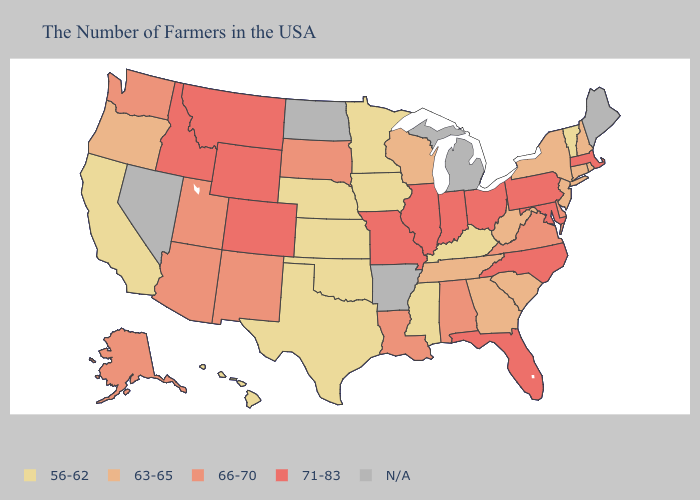Which states hav the highest value in the Northeast?
Keep it brief. Massachusetts, Pennsylvania. Does North Carolina have the lowest value in the South?
Be succinct. No. Is the legend a continuous bar?
Quick response, please. No. Is the legend a continuous bar?
Short answer required. No. Name the states that have a value in the range N/A?
Give a very brief answer. Maine, Michigan, Arkansas, North Dakota, Nevada. What is the value of Kansas?
Give a very brief answer. 56-62. Which states have the lowest value in the USA?
Quick response, please. Vermont, Kentucky, Mississippi, Minnesota, Iowa, Kansas, Nebraska, Oklahoma, Texas, California, Hawaii. Is the legend a continuous bar?
Quick response, please. No. What is the highest value in the Northeast ?
Be succinct. 71-83. What is the value of Nevada?
Be succinct. N/A. Does the map have missing data?
Answer briefly. Yes. What is the value of Wisconsin?
Be succinct. 63-65. Which states have the highest value in the USA?
Give a very brief answer. Massachusetts, Maryland, Pennsylvania, North Carolina, Ohio, Florida, Indiana, Illinois, Missouri, Wyoming, Colorado, Montana, Idaho. Does Hawaii have the lowest value in the USA?
Answer briefly. Yes. 